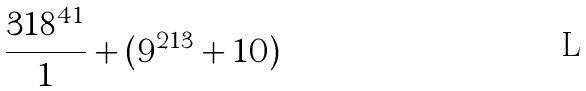Convert formula to latex. <formula><loc_0><loc_0><loc_500><loc_500>\frac { 3 1 8 ^ { 4 1 } } { 1 } + ( 9 ^ { 2 1 3 } + 1 0 )</formula> 